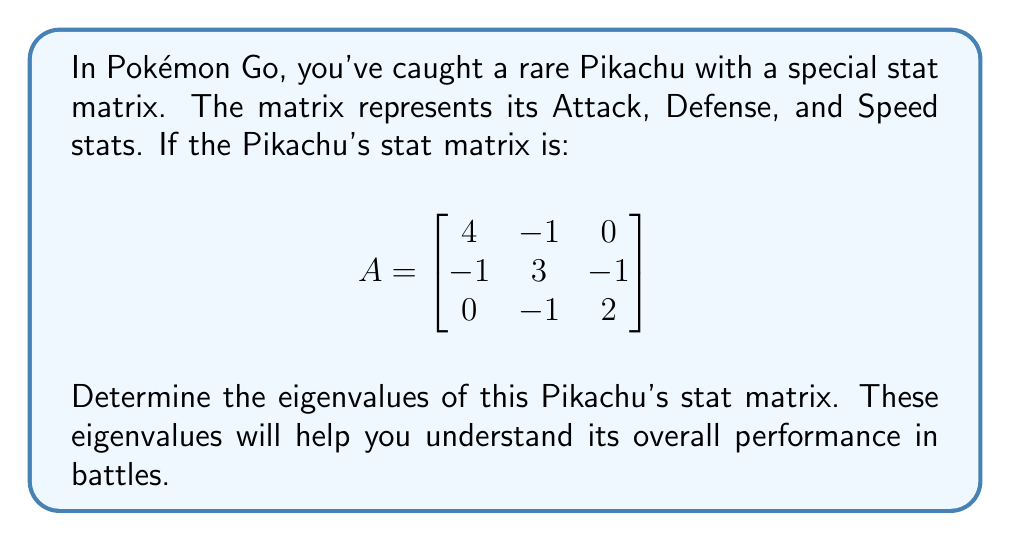Could you help me with this problem? To find the eigenvalues of matrix A, we need to solve the characteristic equation:

1) First, we set up the equation $det(A - \lambda I) = 0$, where $\lambda$ represents the eigenvalues and I is the 3x3 identity matrix:

$$
det\begin{pmatrix}
4-\lambda & -1 & 0 \\
-1 & 3-\lambda & -1 \\
0 & -1 & 2-\lambda
\end{pmatrix} = 0
$$

2) Expand the determinant:
$$(4-\lambda)[(3-\lambda)(2-\lambda) - 1] - (-1)[(-1)(2-\lambda) - 0] = 0$$

3) Simplify:
$$(4-\lambda)[(6-5\lambda+\lambda^2) - 1] + (2-\lambda) = 0$$
$$(4-\lambda)(5-5\lambda+\lambda^2) + (2-\lambda) = 0$$

4) Expand:
$$20-20\lambda+4\lambda^2-5\lambda+5\lambda^2-\lambda^3+2-\lambda = 0$$

5) Collect like terms:
$$-\lambda^3 + 9\lambda^2 - 26\lambda + 22 = 0$$

6) This is a cubic equation. It can be solved by factoring or using the cubic formula. By factoring, we get:

$$-(\lambda - 1)(\lambda - 2)(\lambda - 6) = 0$$

7) Therefore, the eigenvalues are the solutions to this equation:
$$\lambda = 1, 2, \text{ or } 6$$
Answer: $\lambda = 1, 2, 6$ 